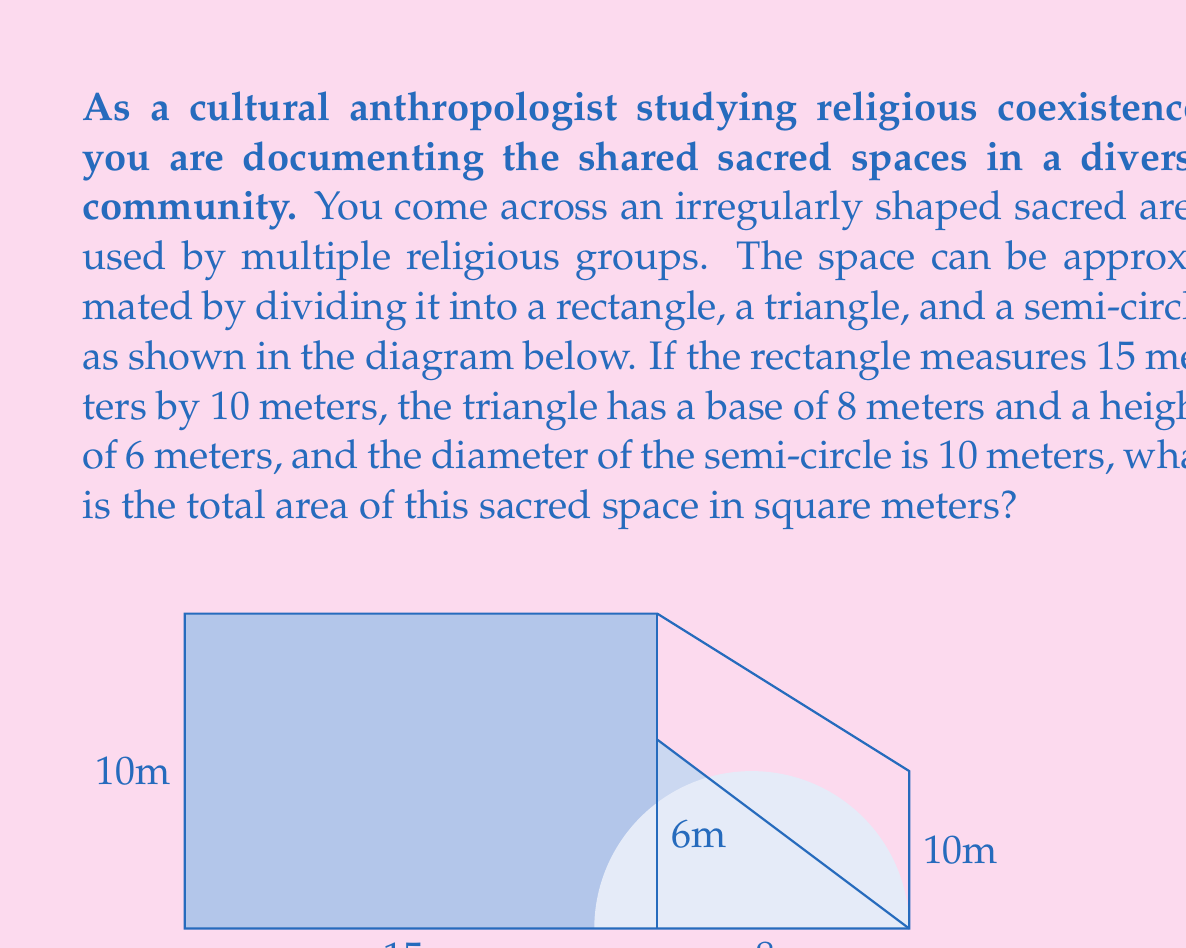Provide a solution to this math problem. To solve this problem, we need to calculate the areas of each component and then sum them up:

1. Rectangle:
   Area of rectangle = length × width
   $A_r = 15 \times 10 = 150$ m²

2. Triangle:
   Area of triangle = $\frac{1}{2} \times$ base × height
   $A_t = \frac{1}{2} \times 8 \times 6 = 24$ m²

3. Semi-circle:
   Area of semi-circle = $\frac{1}{2} \times \pi r^2$, where $r$ is the radius (half the diameter)
   $A_s = \frac{1}{2} \times \pi \times (\frac{10}{2})^2 = \frac{1}{2} \times \pi \times 25 = \frac{25\pi}{2}$ m²

Now, we sum up all the areas:

Total Area = $A_r + A_t + A_s$
           = $150 + 24 + \frac{25\pi}{2}$
           = $174 + \frac{25\pi}{2}$ m²

To simplify further:
$174 + \frac{25\pi}{2} \approx 174 + 39.27 = 213.27$ m²
Answer: The total area of the sacred space is $174 + \frac{25\pi}{2}$ square meters, or approximately 213.27 square meters. 